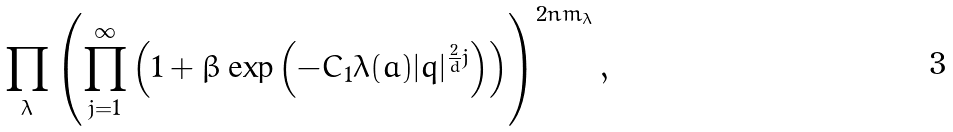<formula> <loc_0><loc_0><loc_500><loc_500>\prod _ { \lambda } \left ( \prod ^ { \infty } _ { j = 1 } \left ( 1 + \beta \exp \left ( - C _ { 1 } \lambda ( a ) | q | ^ { \frac { 2 } { d } j } \right ) \right ) \right ) ^ { 2 n m _ { \lambda } } ,</formula> 